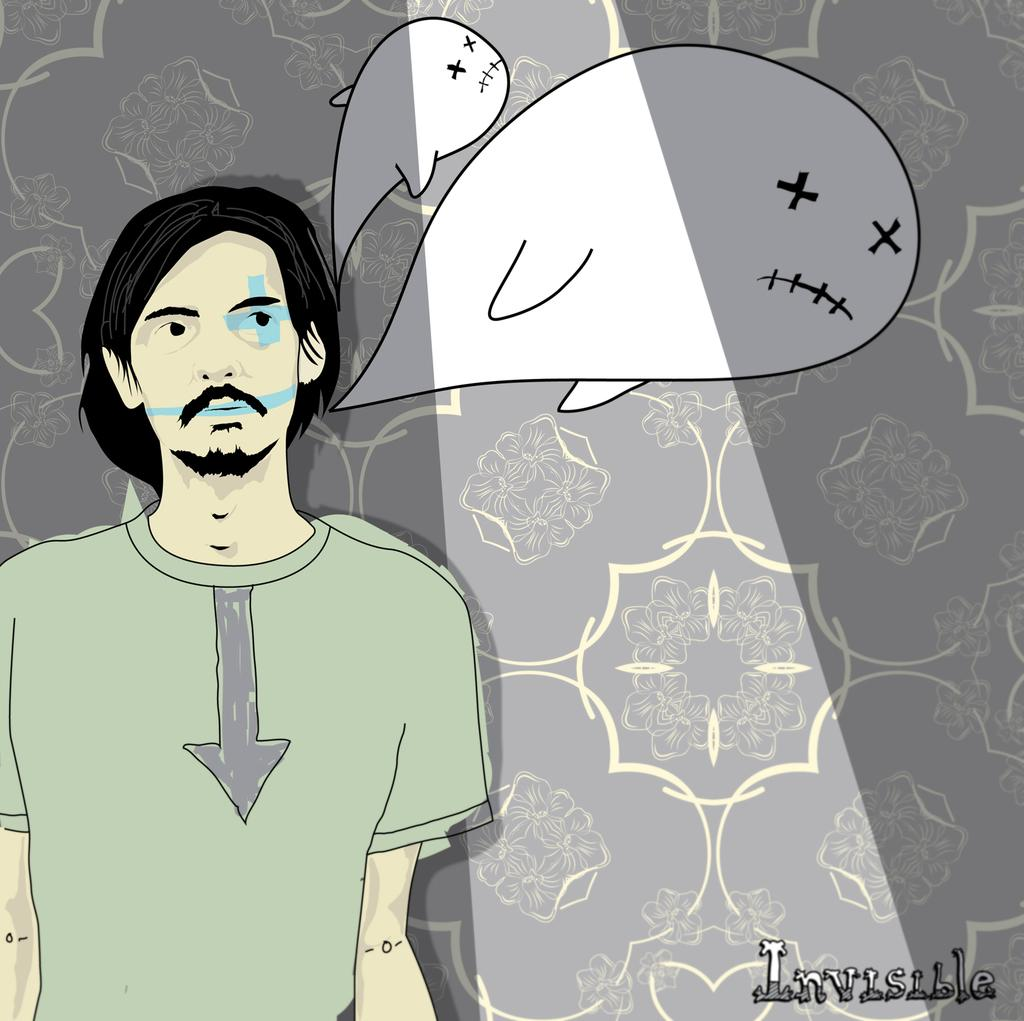What type of image is in the picture? There is a cartoon image of a guy in the picture. What is the guy in the picture thinking about? The guy is thinking about dolphins. Is there any text or marking at the bottom of the image? Yes, there is a watermark named "INVISIBLE" at the bottom of the image. What type of kettle is being used by the doctor to support the patient in the image? There is no kettle, doctor, or patient present in the image; it features a cartoon image of a guy thinking about dolphins. 